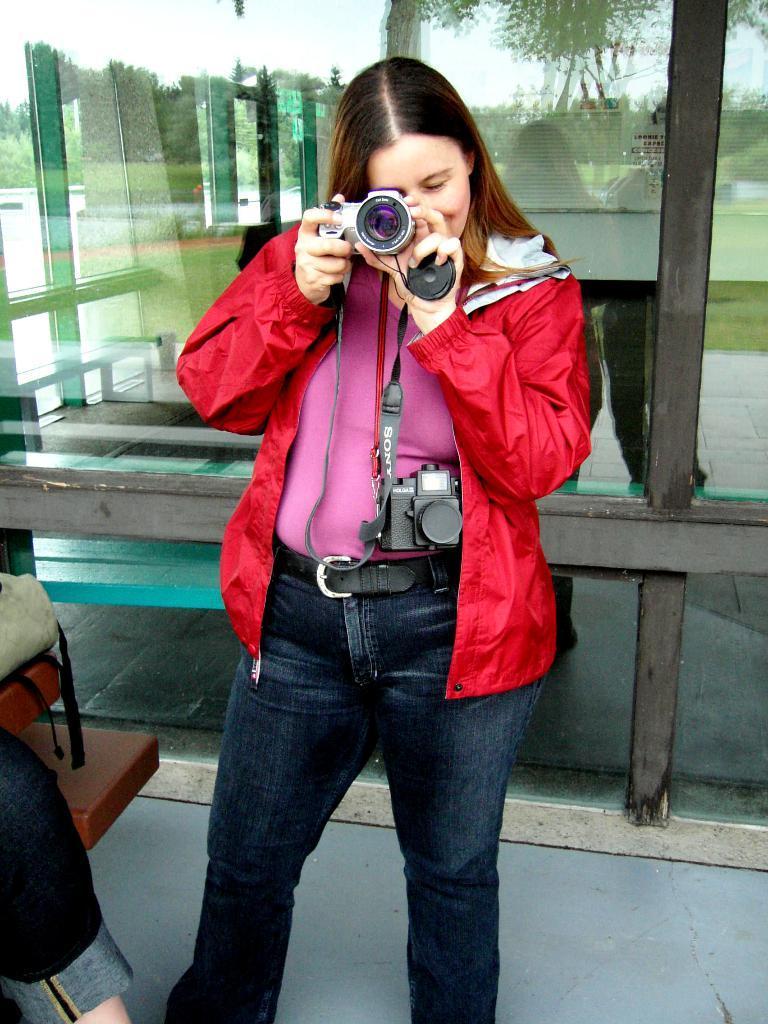Can you describe this image briefly? This girl in red jacket is standing and holding a camera. In a glass there is a reflection of trees and building. 